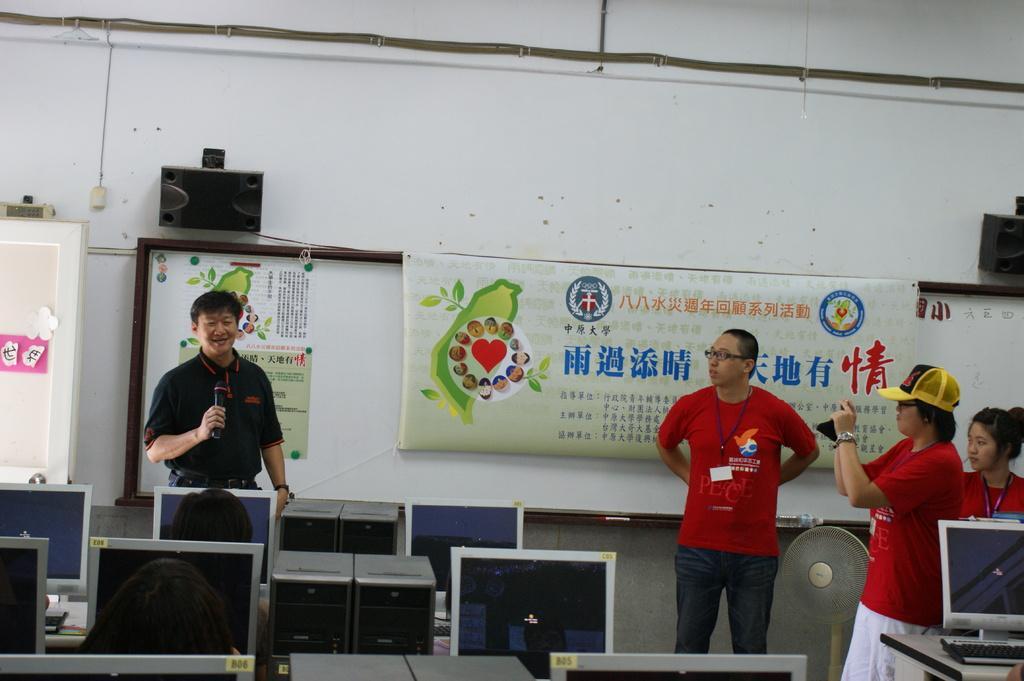Could you give a brief overview of what you see in this image? In this image there are two men and two women are standing. The man to the left is holding a microphone in his hand. The woman to the right is holding a mobile phone in her hand. Behind them there is a whiteboard on the wall. There are banners on the wall. Above the board there are speakers on the wall. To the left there is a window to the wall. At the bottom there are computers. 